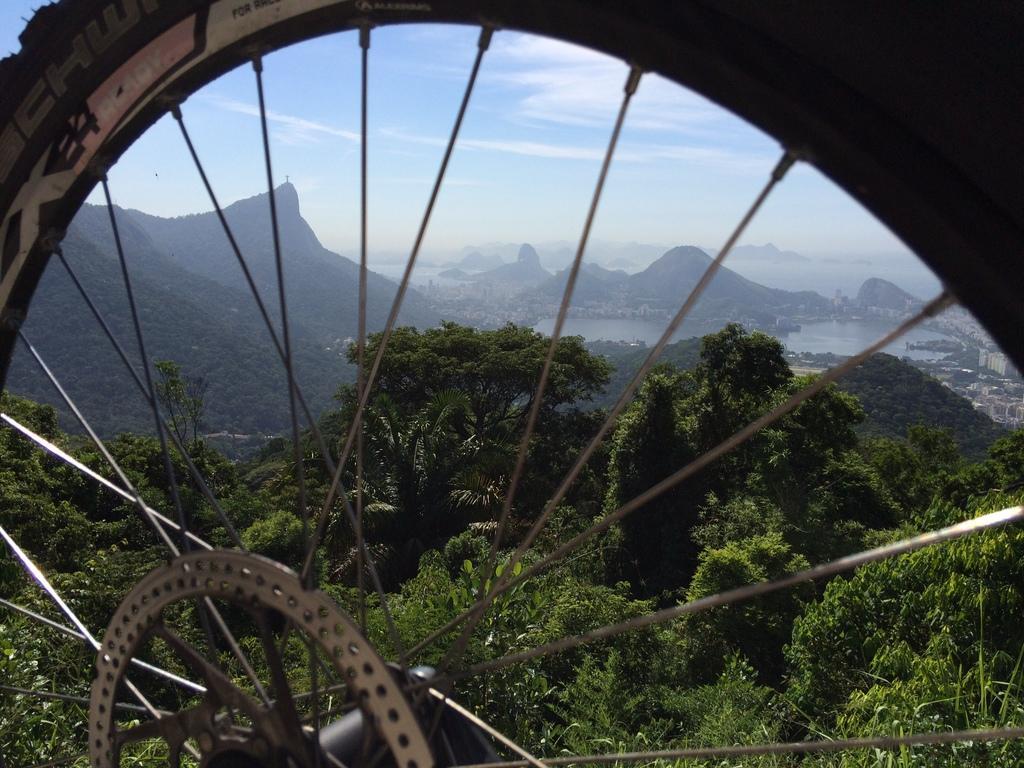Describe this image in one or two sentences. There is a wheel. Here we can see trees, water, and mountain. In the background there is sky. 